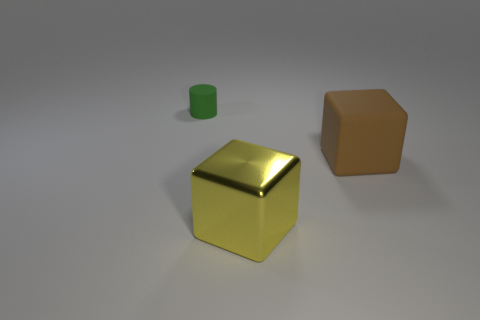Subtract all cubes. How many objects are left? 1 Subtract 1 cubes. How many cubes are left? 1 Add 3 big brown metal balls. How many objects exist? 6 Subtract 0 cyan blocks. How many objects are left? 3 Subtract all red cylinders. Subtract all gray blocks. How many cylinders are left? 1 Subtract all purple cylinders. How many gray blocks are left? 0 Subtract all small purple rubber things. Subtract all big brown things. How many objects are left? 2 Add 2 green objects. How many green objects are left? 3 Add 1 brown rubber things. How many brown rubber things exist? 2 